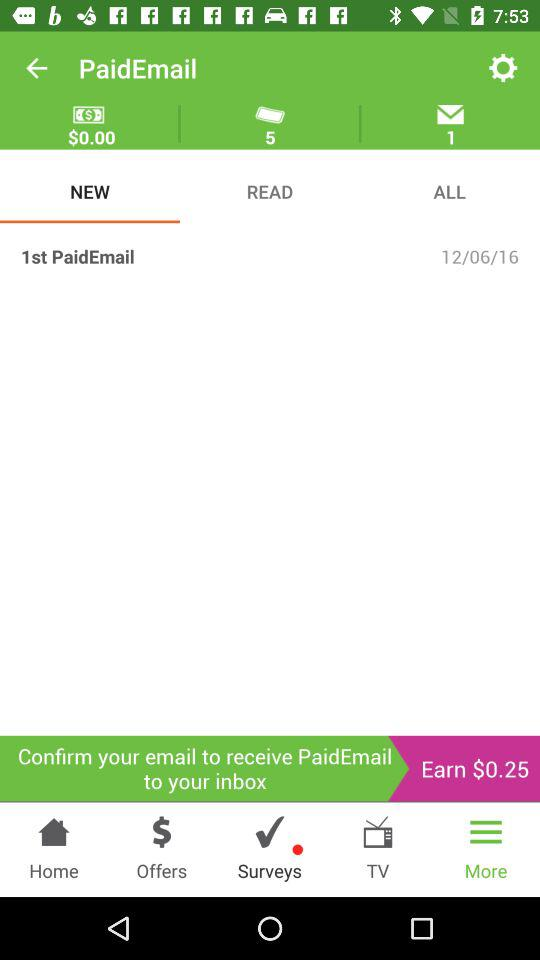How many pending messages are there to be opened? There is 1 pending message. 